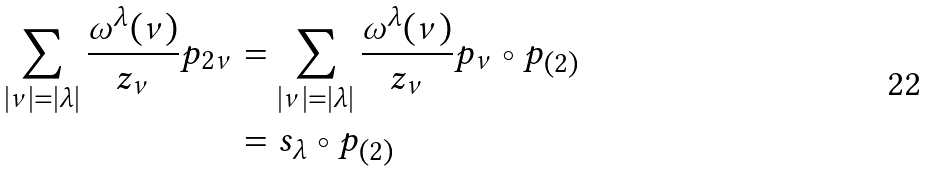<formula> <loc_0><loc_0><loc_500><loc_500>\sum _ { | \nu | = | \lambda | } \frac { \omega ^ { \lambda } ( \nu ) } { z _ { \nu } } p _ { 2 \nu } & = \sum _ { | \nu | = | \lambda | } \frac { \omega ^ { \lambda } ( \nu ) } { z _ { \nu } } p _ { \nu } \circ p _ { ( 2 ) } \\ & = s _ { \lambda } \circ p _ { ( 2 ) }</formula> 